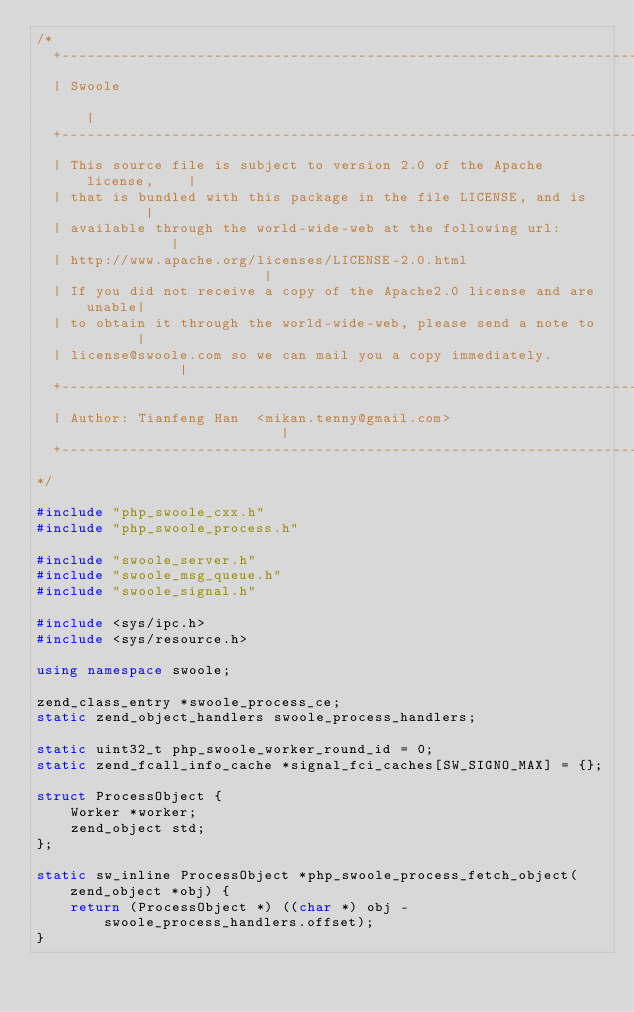Convert code to text. <code><loc_0><loc_0><loc_500><loc_500><_C++_>/*
  +----------------------------------------------------------------------+
  | Swoole                                                               |
  +----------------------------------------------------------------------+
  | This source file is subject to version 2.0 of the Apache license,    |
  | that is bundled with this package in the file LICENSE, and is        |
  | available through the world-wide-web at the following url:           |
  | http://www.apache.org/licenses/LICENSE-2.0.html                      |
  | If you did not receive a copy of the Apache2.0 license and are unable|
  | to obtain it through the world-wide-web, please send a note to       |
  | license@swoole.com so we can mail you a copy immediately.            |
  +----------------------------------------------------------------------+
  | Author: Tianfeng Han  <mikan.tenny@gmail.com>                        |
  +----------------------------------------------------------------------+
*/

#include "php_swoole_cxx.h"
#include "php_swoole_process.h"

#include "swoole_server.h"
#include "swoole_msg_queue.h"
#include "swoole_signal.h"

#include <sys/ipc.h>
#include <sys/resource.h>

using namespace swoole;

zend_class_entry *swoole_process_ce;
static zend_object_handlers swoole_process_handlers;

static uint32_t php_swoole_worker_round_id = 0;
static zend_fcall_info_cache *signal_fci_caches[SW_SIGNO_MAX] = {};

struct ProcessObject {
    Worker *worker;
    zend_object std;
};

static sw_inline ProcessObject *php_swoole_process_fetch_object(zend_object *obj) {
    return (ProcessObject *) ((char *) obj - swoole_process_handlers.offset);
}
</code> 